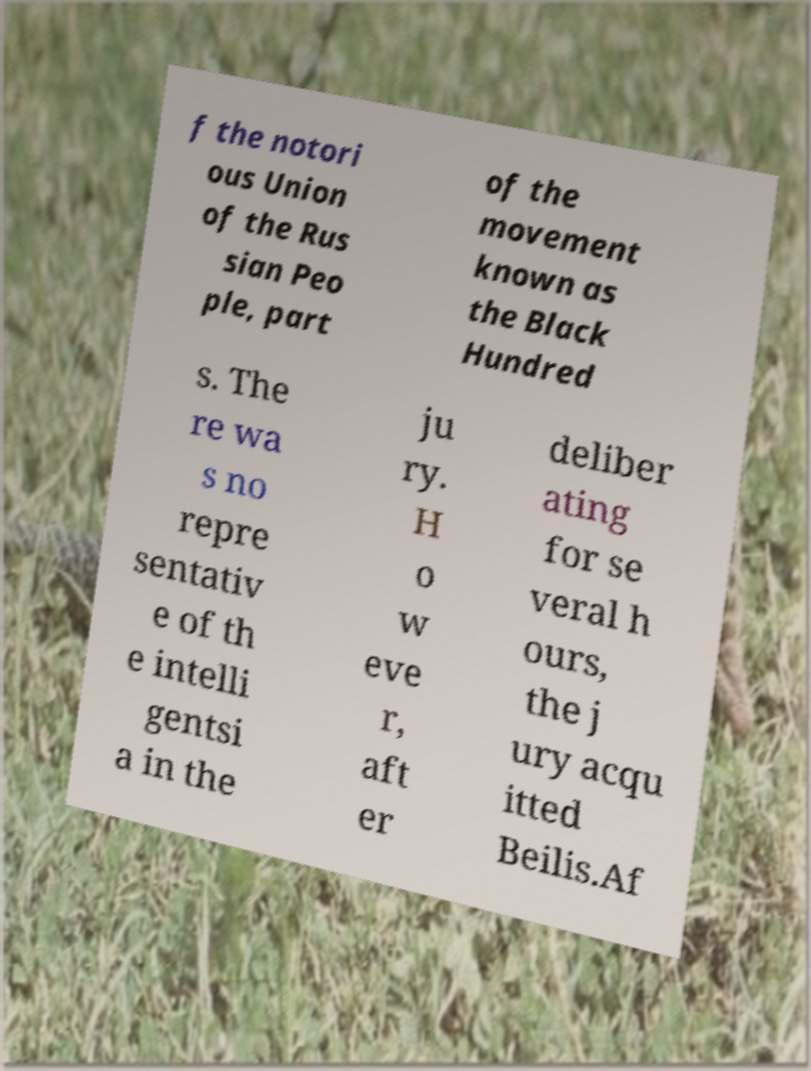I need the written content from this picture converted into text. Can you do that? f the notori ous Union of the Rus sian Peo ple, part of the movement known as the Black Hundred s. The re wa s no repre sentativ e of th e intelli gentsi a in the ju ry. H o w eve r, aft er deliber ating for se veral h ours, the j ury acqu itted Beilis.Af 